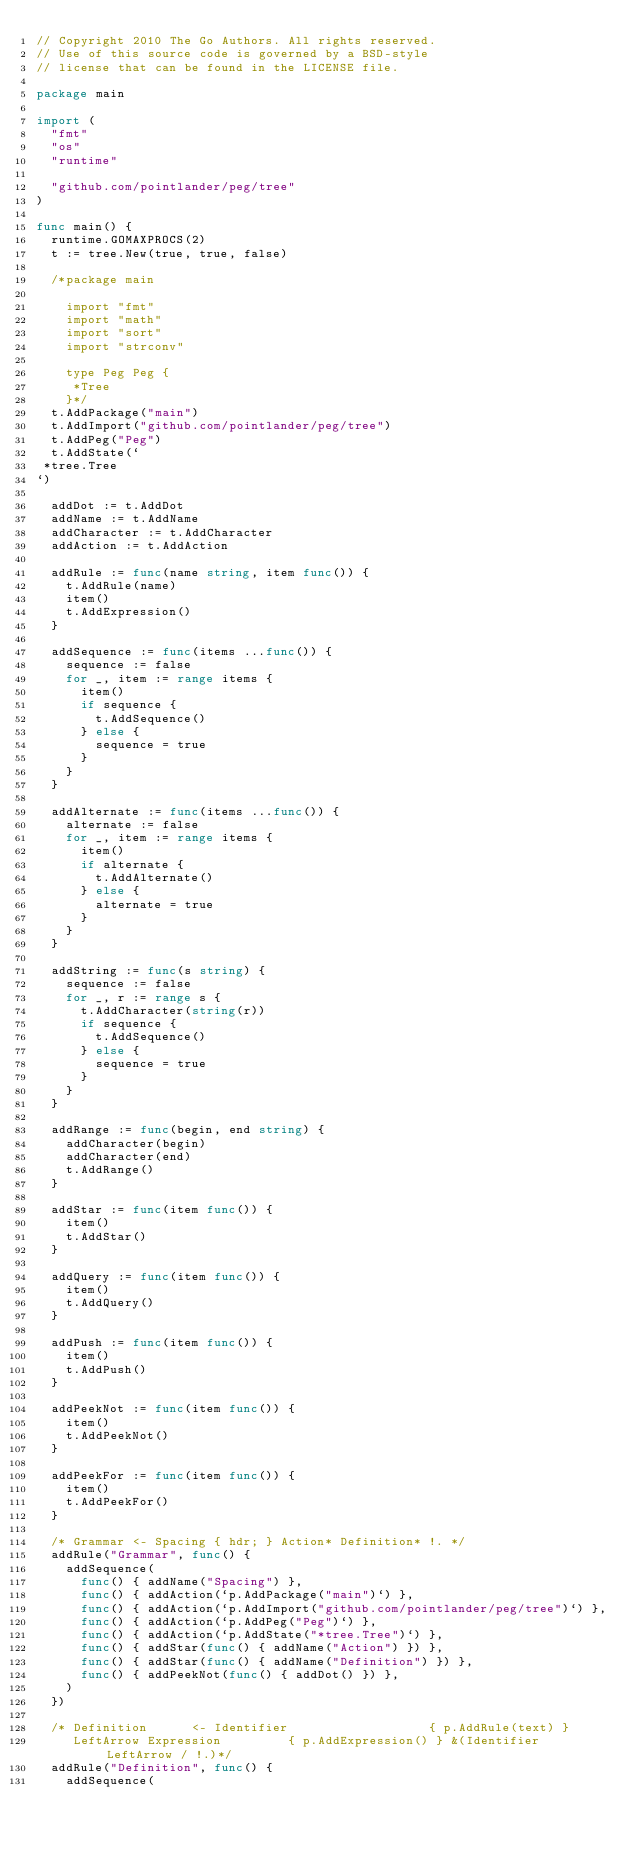Convert code to text. <code><loc_0><loc_0><loc_500><loc_500><_Go_>// Copyright 2010 The Go Authors. All rights reserved.
// Use of this source code is governed by a BSD-style
// license that can be found in the LICENSE file.

package main

import (
	"fmt"
	"os"
	"runtime"

	"github.com/pointlander/peg/tree"
)

func main() {
	runtime.GOMAXPROCS(2)
	t := tree.New(true, true, false)

	/*package main

	  import "fmt"
	  import "math"
	  import "sort"
	  import "strconv"

	  type Peg Peg {
	   *Tree
	  }*/
	t.AddPackage("main")
	t.AddImport("github.com/pointlander/peg/tree")
	t.AddPeg("Peg")
	t.AddState(`
 *tree.Tree
`)

	addDot := t.AddDot
	addName := t.AddName
	addCharacter := t.AddCharacter
	addAction := t.AddAction

	addRule := func(name string, item func()) {
		t.AddRule(name)
		item()
		t.AddExpression()
	}

	addSequence := func(items ...func()) {
		sequence := false
		for _, item := range items {
			item()
			if sequence {
				t.AddSequence()
			} else {
				sequence = true
			}
		}
	}

	addAlternate := func(items ...func()) {
		alternate := false
		for _, item := range items {
			item()
			if alternate {
				t.AddAlternate()
			} else {
				alternate = true
			}
		}
	}

	addString := func(s string) {
		sequence := false
		for _, r := range s {
			t.AddCharacter(string(r))
			if sequence {
				t.AddSequence()
			} else {
				sequence = true
			}
		}
	}

	addRange := func(begin, end string) {
		addCharacter(begin)
		addCharacter(end)
		t.AddRange()
	}

	addStar := func(item func()) {
		item()
		t.AddStar()
	}

	addQuery := func(item func()) {
		item()
		t.AddQuery()
	}

	addPush := func(item func()) {
		item()
		t.AddPush()
	}

	addPeekNot := func(item func()) {
		item()
		t.AddPeekNot()
	}

	addPeekFor := func(item func()) {
		item()
		t.AddPeekFor()
	}

	/* Grammar <- Spacing { hdr; } Action* Definition* !. */
	addRule("Grammar", func() {
		addSequence(
			func() { addName("Spacing") },
			func() { addAction(`p.AddPackage("main")`) },
			func() { addAction(`p.AddImport("github.com/pointlander/peg/tree")`) },
			func() { addAction(`p.AddPeg("Peg")`) },
			func() { addAction(`p.AddState("*tree.Tree")`) },
			func() { addStar(func() { addName("Action") }) },
			func() { addStar(func() { addName("Definition") }) },
			func() { addPeekNot(func() { addDot() }) },
		)
	})

	/* Definition      <- Identifier                   { p.AddRule(text) }
	   LeftArrow Expression         { p.AddExpression() } &(Identifier LeftArrow / !.)*/
	addRule("Definition", func() {
		addSequence(</code> 